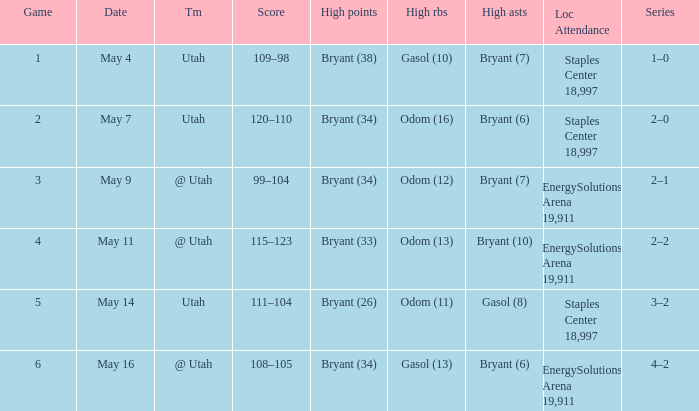What is the Series with a High rebounds with gasol (10)? 1–0. 